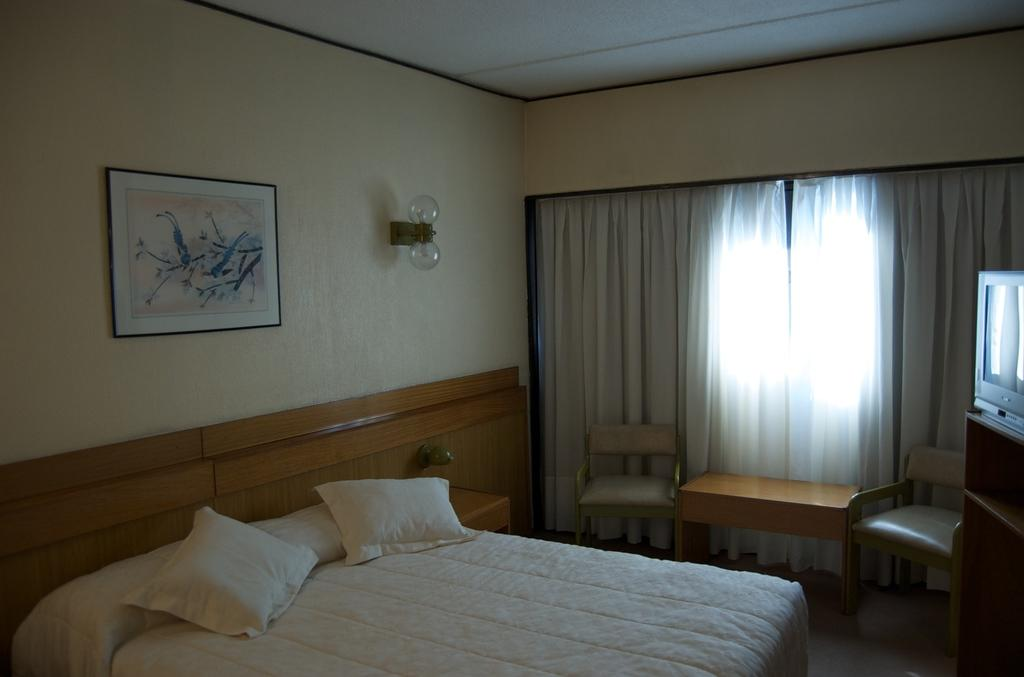What piece of furniture is the main subject in the image? There is a bed in the image. What can be seen on the bed? There are two white pillows on the bed. What other piece of furniture is present in the image? There is a chair in front of the bed. What is attached to the wall in the image? There is a frame attached to the wall. What color is the wall in the image? The wall is in cream color. How many passengers are visible in the image? There are no passengers present in the image. What type of achievement is being celebrated in the image? There is no celebration or achievement depicted in the image. 